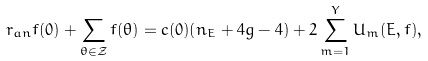Convert formula to latex. <formula><loc_0><loc_0><loc_500><loc_500>r _ { a n } f ( 0 ) + \sum _ { \theta \in \mathcal { Z } } f ( \theta ) = c ( 0 ) ( n _ { E } + 4 g - 4 ) + 2 \sum _ { m = 1 } ^ { Y } U _ { m } ( E , f ) ,</formula> 